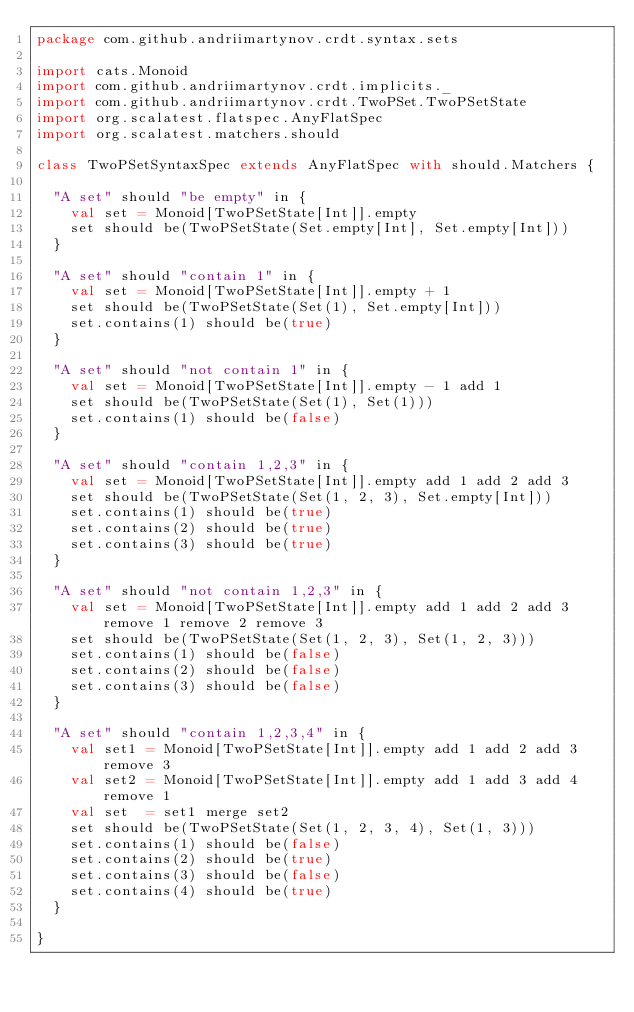Convert code to text. <code><loc_0><loc_0><loc_500><loc_500><_Scala_>package com.github.andriimartynov.crdt.syntax.sets

import cats.Monoid
import com.github.andriimartynov.crdt.implicits._
import com.github.andriimartynov.crdt.TwoPSet.TwoPSetState
import org.scalatest.flatspec.AnyFlatSpec
import org.scalatest.matchers.should

class TwoPSetSyntaxSpec extends AnyFlatSpec with should.Matchers {

  "A set" should "be empty" in {
    val set = Monoid[TwoPSetState[Int]].empty
    set should be(TwoPSetState(Set.empty[Int], Set.empty[Int]))
  }

  "A set" should "contain 1" in {
    val set = Monoid[TwoPSetState[Int]].empty + 1
    set should be(TwoPSetState(Set(1), Set.empty[Int]))
    set.contains(1) should be(true)
  }

  "A set" should "not contain 1" in {
    val set = Monoid[TwoPSetState[Int]].empty - 1 add 1
    set should be(TwoPSetState(Set(1), Set(1)))
    set.contains(1) should be(false)
  }

  "A set" should "contain 1,2,3" in {
    val set = Monoid[TwoPSetState[Int]].empty add 1 add 2 add 3
    set should be(TwoPSetState(Set(1, 2, 3), Set.empty[Int]))
    set.contains(1) should be(true)
    set.contains(2) should be(true)
    set.contains(3) should be(true)
  }

  "A set" should "not contain 1,2,3" in {
    val set = Monoid[TwoPSetState[Int]].empty add 1 add 2 add 3 remove 1 remove 2 remove 3
    set should be(TwoPSetState(Set(1, 2, 3), Set(1, 2, 3)))
    set.contains(1) should be(false)
    set.contains(2) should be(false)
    set.contains(3) should be(false)
  }

  "A set" should "contain 1,2,3,4" in {
    val set1 = Monoid[TwoPSetState[Int]].empty add 1 add 2 add 3 remove 3
    val set2 = Monoid[TwoPSetState[Int]].empty add 1 add 3 add 4 remove 1
    val set  = set1 merge set2
    set should be(TwoPSetState(Set(1, 2, 3, 4), Set(1, 3)))
    set.contains(1) should be(false)
    set.contains(2) should be(true)
    set.contains(3) should be(false)
    set.contains(4) should be(true)
  }

}
</code> 